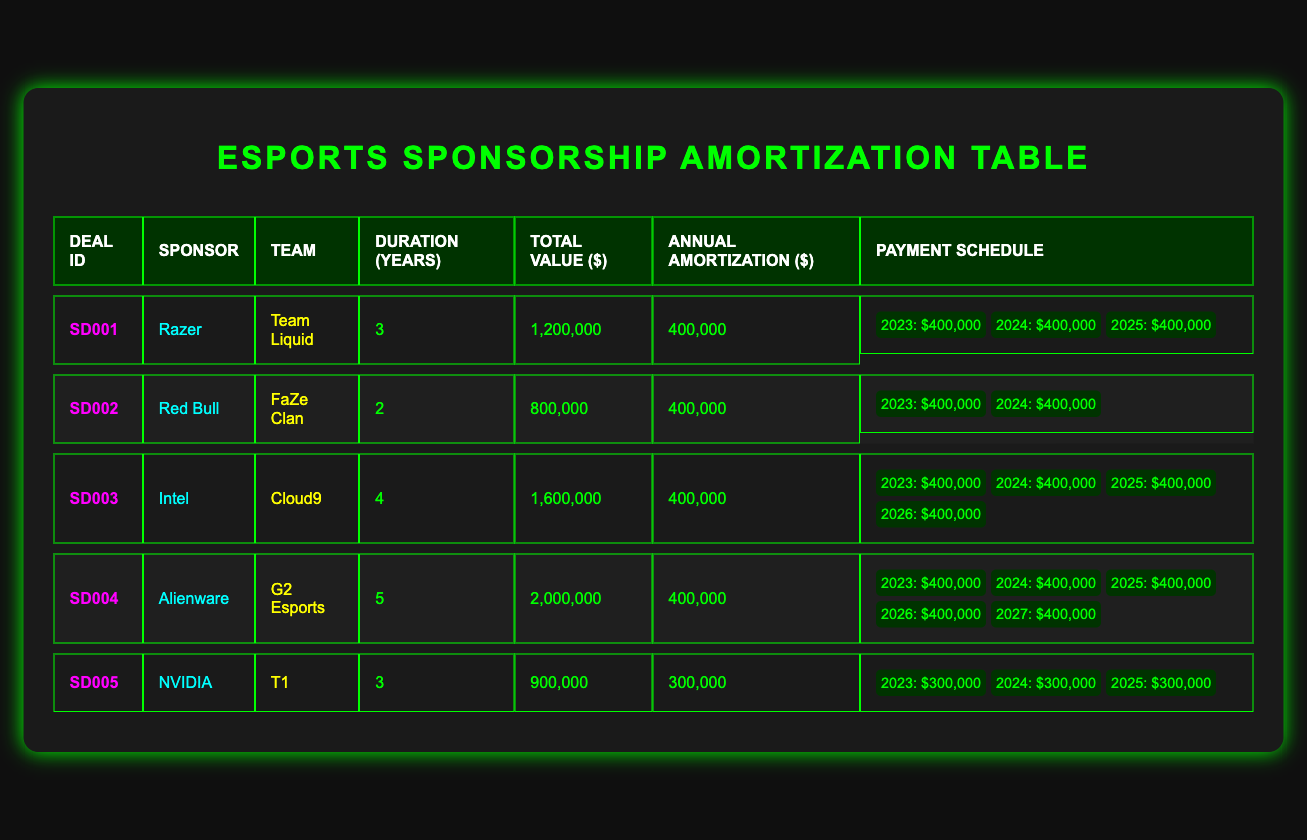What is the total deal value for the sponsorship deal with Razer? The total deal value for the sponsorship deal with Razer is listed in the table under the "Total Value ($)" column for "Razer" which is $1,200,000.
Answer: 1,200,000 How many teams have a contract duration of 3 years? By checking the "Duration (Years)" column, we find that both "Team Liquid" (Razer) and "T1" (NVIDIA) have contracts lasting 3 years. Thus, there are 2 teams with a 3-year duration.
Answer: 2 What is the annual amortization amount for the sponsorship deal with Alienware? The annual amortization for Alienware is found in the "Annual Amortization ($)" column for "G2 Esports", which states the amount is $400,000.
Answer: 400,000 Is Red Bull's sponsorship deal longer than 3 years? The "Duration (Years)" column shows that Red Bull's sponsorship deal with "FaZe Clan" is for 2 years, which is shorter than 3 years. Thus, the answer is no.
Answer: No How much total payment will Razer make over the duration of the contract? To find the total payment for the Razer sponsorship deal, we multiply the annual amortization by the contract duration: 400,000 * 3 = 1,200,000. Therefore, the total payment is $1,200,000.
Answer: 1,200,000 What is the average annual amortization amount across all listed sponsorship deals? We total up the annual amortization amounts: $400,000 (Razer) + $400,000 (Red Bull) + $400,000 (Intel) + $400,000 (Alienware) + $300,000 (NVIDIA) = $1,900,000. Dividing by the 5 deals gives an average of $1,900,000 / 5 = $380,000.
Answer: 380,000 Do all teams have the same annual amortization amount? In the table, the amounts are $400,000 for Razer, Red Bull, Intel, and Alienware, and $300,000 for NVIDIA. Since not all teams have the same amount, the answer is no.
Answer: No 